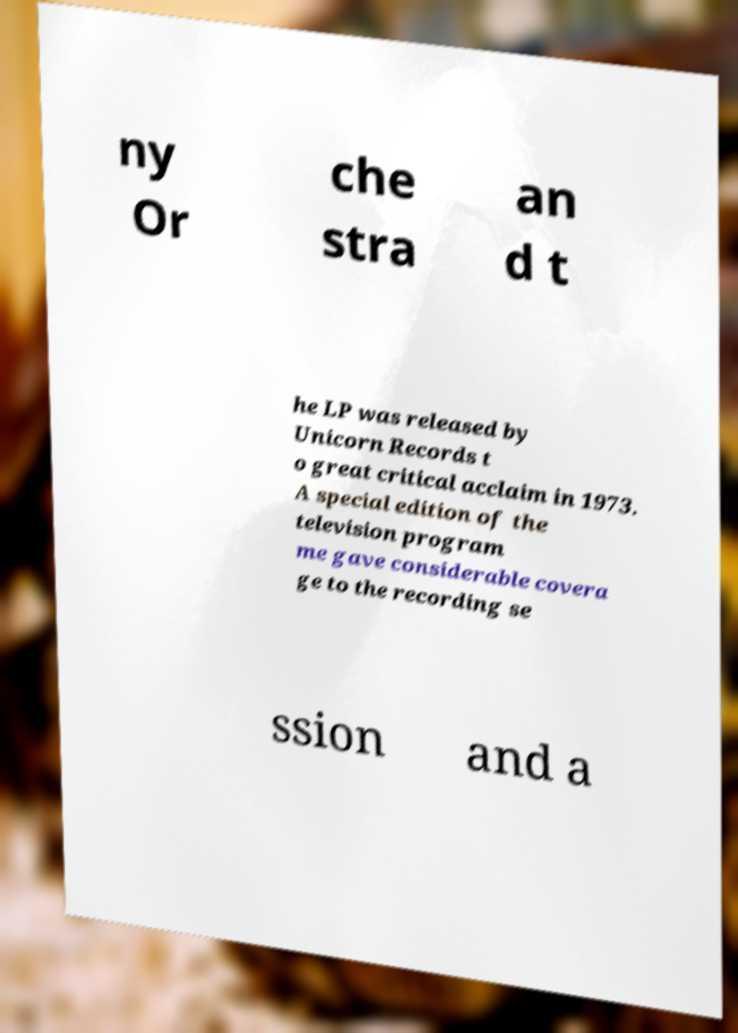Can you accurately transcribe the text from the provided image for me? ny Or che stra an d t he LP was released by Unicorn Records t o great critical acclaim in 1973. A special edition of the television program me gave considerable covera ge to the recording se ssion and a 